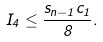<formula> <loc_0><loc_0><loc_500><loc_500>I _ { 4 } \leq \frac { s _ { n - 1 } c _ { 1 } } { 8 } .</formula> 